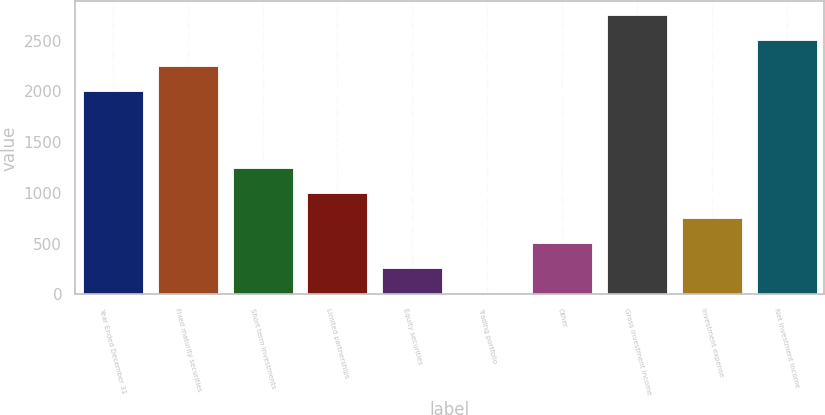<chart> <loc_0><loc_0><loc_500><loc_500><bar_chart><fcel>Year Ended December 31<fcel>Fixed maturity securities<fcel>Short term investments<fcel>Limited partnerships<fcel>Equity securities<fcel>Trading portfolio<fcel>Other<fcel>Gross investment income<fcel>Investment expense<fcel>Net investment income<nl><fcel>2007<fcel>2254.6<fcel>1248<fcel>1000.4<fcel>257.6<fcel>10<fcel>505.2<fcel>2749.8<fcel>752.8<fcel>2502.2<nl></chart> 